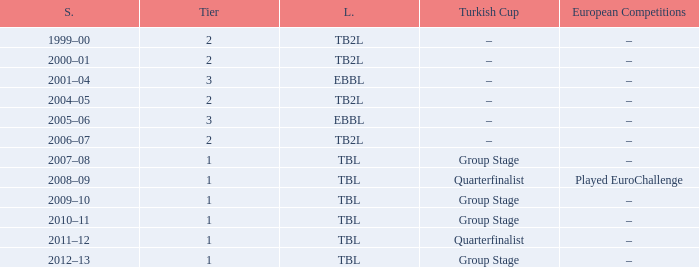Tier of 2, and a Season of 2004–05 is what European competitions? –. 